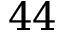<formula> <loc_0><loc_0><loc_500><loc_500>4 4</formula> 